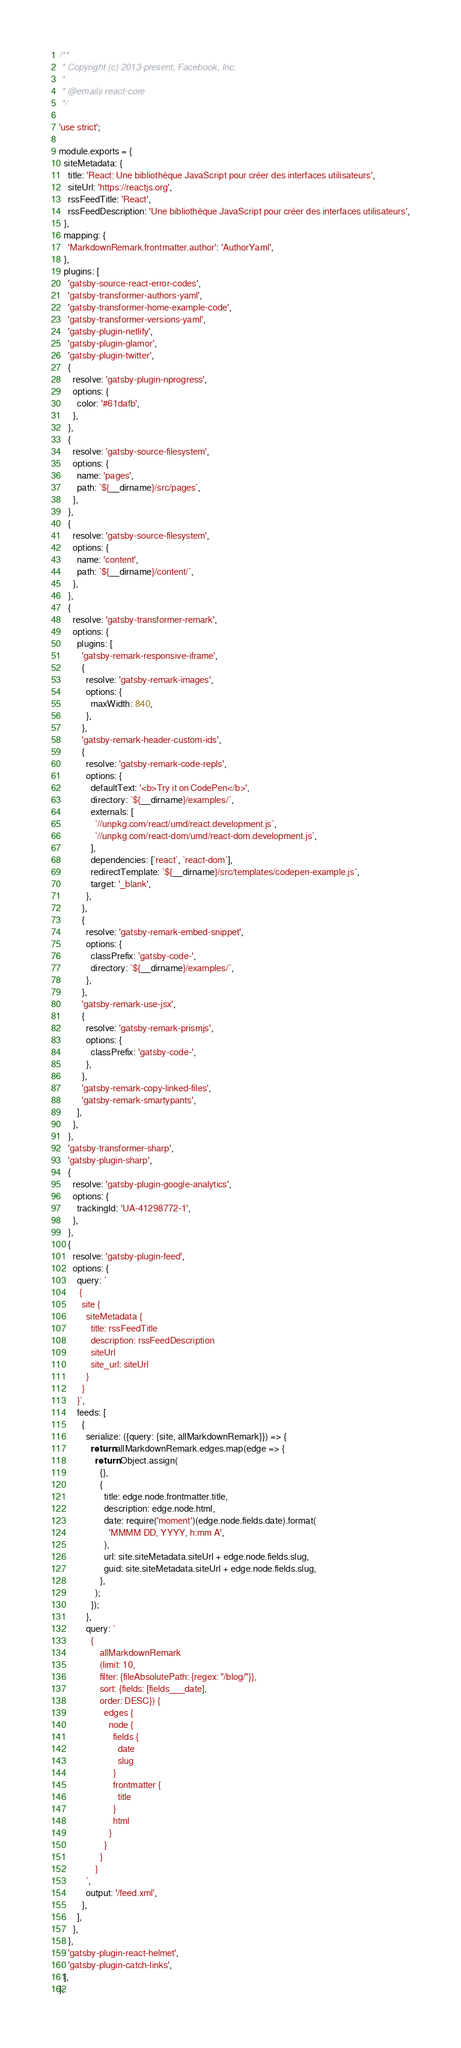<code> <loc_0><loc_0><loc_500><loc_500><_JavaScript_>/**
 * Copyright (c) 2013-present, Facebook, Inc.
 *
 * @emails react-core
 */

'use strict';

module.exports = {
  siteMetadata: {
    title: 'React: Une bibliothèque JavaScript pour créer des interfaces utilisateurs',
    siteUrl: 'https://reactjs.org',
    rssFeedTitle: 'React',
    rssFeedDescription: 'Une bibliothèque JavaScript pour créer des interfaces utilisateurs',
  },
  mapping: {
    'MarkdownRemark.frontmatter.author': 'AuthorYaml',
  },
  plugins: [
    'gatsby-source-react-error-codes',
    'gatsby-transformer-authors-yaml',
    'gatsby-transformer-home-example-code',
    'gatsby-transformer-versions-yaml',
    'gatsby-plugin-netlify',
    'gatsby-plugin-glamor',
    'gatsby-plugin-twitter',
    {
      resolve: 'gatsby-plugin-nprogress',
      options: {
        color: '#61dafb',
      },
    },
    {
      resolve: 'gatsby-source-filesystem',
      options: {
        name: 'pages',
        path: `${__dirname}/src/pages`,
      },
    },
    {
      resolve: 'gatsby-source-filesystem',
      options: {
        name: 'content',
        path: `${__dirname}/content/`,
      },
    },
    {
      resolve: 'gatsby-transformer-remark',
      options: {
        plugins: [
          'gatsby-remark-responsive-iframe',
          {
            resolve: 'gatsby-remark-images',
            options: {
              maxWidth: 840,
            },
          },
          'gatsby-remark-header-custom-ids',
          {
            resolve: 'gatsby-remark-code-repls',
            options: {
              defaultText: '<b>Try it on CodePen</b>',
              directory: `${__dirname}/examples/`,
              externals: [
                `//unpkg.com/react/umd/react.development.js`,
                `//unpkg.com/react-dom/umd/react-dom.development.js`,
              ],
              dependencies: [`react`, `react-dom`],
              redirectTemplate: `${__dirname}/src/templates/codepen-example.js`,
              target: '_blank',
            },
          },
          {
            resolve: 'gatsby-remark-embed-snippet',
            options: {
              classPrefix: 'gatsby-code-',
              directory: `${__dirname}/examples/`,
            },
          },
          'gatsby-remark-use-jsx',
          {
            resolve: 'gatsby-remark-prismjs',
            options: {
              classPrefix: 'gatsby-code-',
            },
          },
          'gatsby-remark-copy-linked-files',
          'gatsby-remark-smartypants',
        ],
      },
    },
    'gatsby-transformer-sharp',
    'gatsby-plugin-sharp',
    {
      resolve: 'gatsby-plugin-google-analytics',
      options: {
        trackingId: 'UA-41298772-1',
      },
    },
    {
      resolve: 'gatsby-plugin-feed',
      options: {
        query: `
         {
          site {
            siteMetadata {
              title: rssFeedTitle
              description: rssFeedDescription
              siteUrl
              site_url: siteUrl
            }
          }
        }`,
        feeds: [
          {
            serialize: ({query: {site, allMarkdownRemark}}) => {
              return allMarkdownRemark.edges.map(edge => {
                return Object.assign(
                  {},
                  {
                    title: edge.node.frontmatter.title,
                    description: edge.node.html,
                    date: require('moment')(edge.node.fields.date).format(
                      'MMMM DD, YYYY, h:mm A',
                    ),
                    url: site.siteMetadata.siteUrl + edge.node.fields.slug,
                    guid: site.siteMetadata.siteUrl + edge.node.fields.slug,
                  },
                );
              });
            },
            query: `
              {
                  allMarkdownRemark
                  (limit: 10,
                  filter: {fileAbsolutePath: {regex: "/blog/"}},
                  sort: {fields: [fields___date],
                  order: DESC}) {
                    edges {
                      node {
                        fields {
                          date
                          slug
                        }
                        frontmatter {
                          title
                        }
                        html
                      }
                    }
                  }
                }
            `,
            output: '/feed.xml',
          },
        ],
      },
    },
    'gatsby-plugin-react-helmet',
    'gatsby-plugin-catch-links',
  ],
};
</code> 